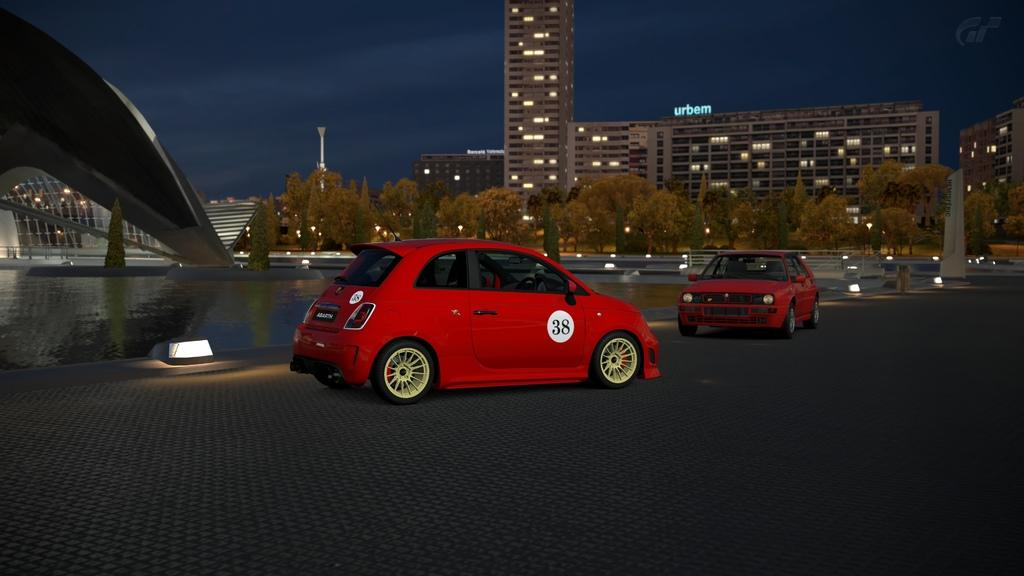What type of vehicles are on the path in the image? There are two red cars on the path in the image. What can be seen in the background of the image? Water, at least one building, lights, poles, and the sky are visible in the background of the image. How many cars are on the path? There are two cars on the path. Can you see any monkeys or fairies in the image? No, there are no monkeys or fairies present in the image. 